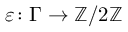<formula> <loc_0><loc_0><loc_500><loc_500>\varepsilon \colon \Gamma \to \mathbb { Z } / 2 \mathbb { Z }</formula> 